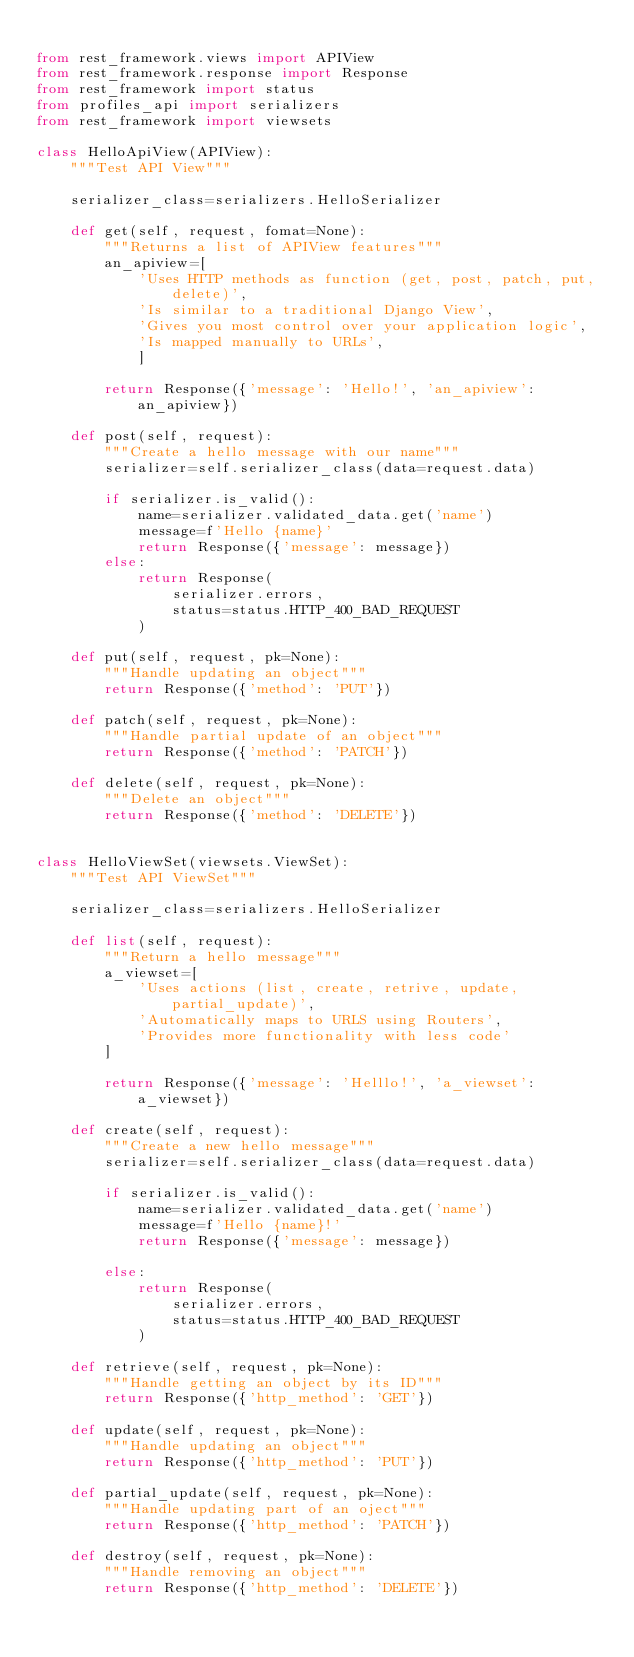<code> <loc_0><loc_0><loc_500><loc_500><_Python_>
from rest_framework.views import APIView
from rest_framework.response import Response
from rest_framework import status
from profiles_api import serializers
from rest_framework import viewsets

class HelloApiView(APIView):
    """Test API View"""

    serializer_class=serializers.HelloSerializer

    def get(self, request, fomat=None):
        """Returns a list of APIView features"""
        an_apiview=[
            'Uses HTTP methods as function (get, post, patch, put, delete)',
            'Is similar to a traditional Django View',
            'Gives you most control over your application logic',
            'Is mapped manually to URLs',
            ]

        return Response({'message': 'Hello!', 'an_apiview': an_apiview})

    def post(self, request):
        """Create a hello message with our name"""
        serializer=self.serializer_class(data=request.data)

        if serializer.is_valid():
            name=serializer.validated_data.get('name')
            message=f'Hello {name}'
            return Response({'message': message})
        else:
            return Response(
                serializer.errors,
                status=status.HTTP_400_BAD_REQUEST
            )

    def put(self, request, pk=None):
        """Handle updating an object"""
        return Response({'method': 'PUT'})

    def patch(self, request, pk=None):
        """Handle partial update of an object"""
        return Response({'method': 'PATCH'})

    def delete(self, request, pk=None):
        """Delete an object"""
        return Response({'method': 'DELETE'})


class HelloViewSet(viewsets.ViewSet):
    """Test API ViewSet"""

    serializer_class=serializers.HelloSerializer

    def list(self, request):
        """Return a hello message"""
        a_viewset=[
            'Uses actions (list, create, retrive, update, partial_update)',
            'Automatically maps to URLS using Routers',
            'Provides more functionality with less code'
        ]

        return Response({'message': 'Helllo!', 'a_viewset': a_viewset})

    def create(self, request):
        """Create a new hello message"""
        serializer=self.serializer_class(data=request.data)

        if serializer.is_valid():
            name=serializer.validated_data.get('name')
            message=f'Hello {name}!'
            return Response({'message': message})

        else:
            return Response(
                serializer.errors,
                status=status.HTTP_400_BAD_REQUEST
            )

    def retrieve(self, request, pk=None):
        """Handle getting an object by its ID"""
        return Response({'http_method': 'GET'})

    def update(self, request, pk=None):
        """Handle updating an object"""
        return Response({'http_method': 'PUT'})

    def partial_update(self, request, pk=None):
        """Handle updating part of an oject"""
        return Response({'http_method': 'PATCH'})

    def destroy(self, request, pk=None):
        """Handle removing an object"""
        return Response({'http_method': 'DELETE'})
</code> 